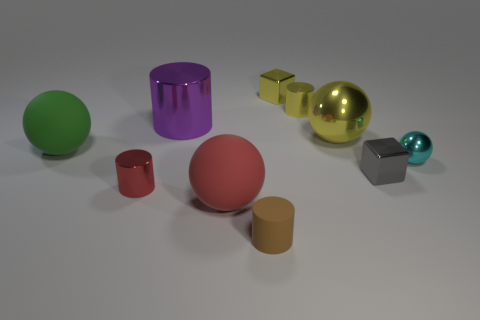Is the brown object made of the same material as the small gray cube?
Make the answer very short. No. What material is the brown thing that is the same shape as the small red metallic object?
Your answer should be compact. Rubber. Is the number of shiny cubes that are right of the tiny metallic sphere less than the number of large brown blocks?
Ensure brevity in your answer.  No. There is a small cyan metallic ball; how many gray objects are in front of it?
Make the answer very short. 1. Do the tiny thing that is on the right side of the small gray metal cube and the big rubber thing that is on the right side of the large green matte object have the same shape?
Ensure brevity in your answer.  Yes. There is a thing that is to the left of the big metal cylinder and in front of the green matte sphere; what shape is it?
Keep it short and to the point. Cylinder. There is a cylinder that is the same material as the green ball; what is its size?
Make the answer very short. Small. Is the number of big green spheres less than the number of large green shiny blocks?
Provide a short and direct response. No. What is the material of the tiny thing that is on the right side of the cube that is to the right of the small cylinder that is behind the tiny gray metallic object?
Your answer should be very brief. Metal. Is the small thing on the right side of the gray shiny cube made of the same material as the large object right of the small brown rubber cylinder?
Provide a short and direct response. Yes. 